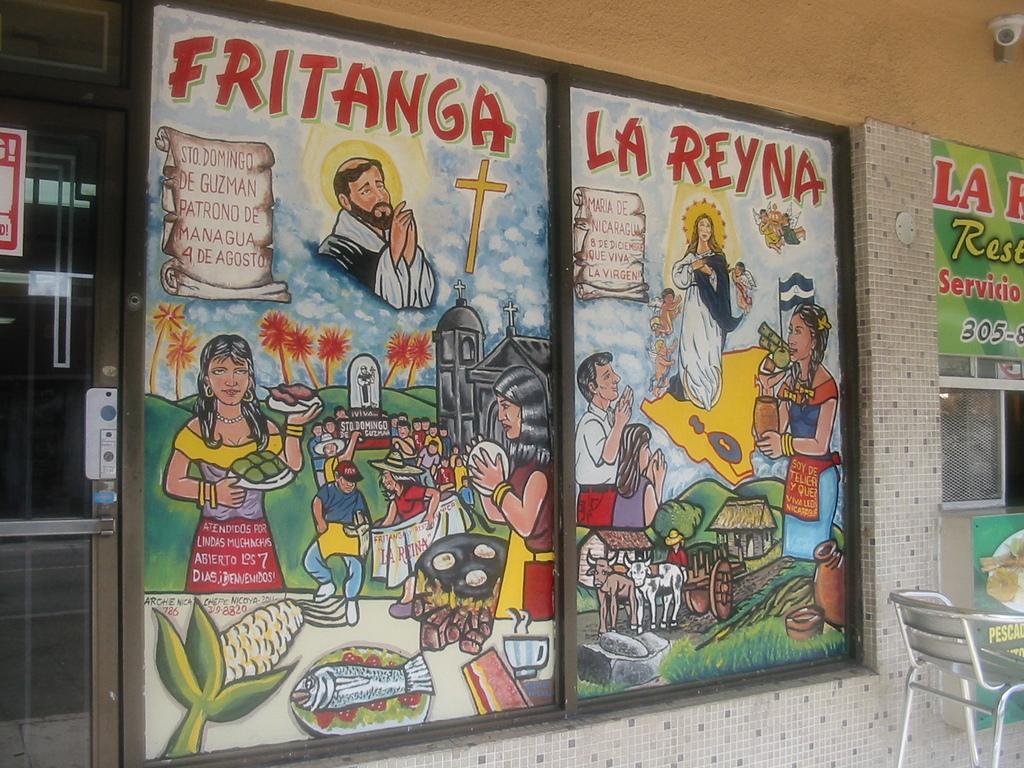What are the first three numbers on the phone number?
Make the answer very short. 305. What is the title of this snippet?
Your answer should be very brief. Fritanga la reyna. 